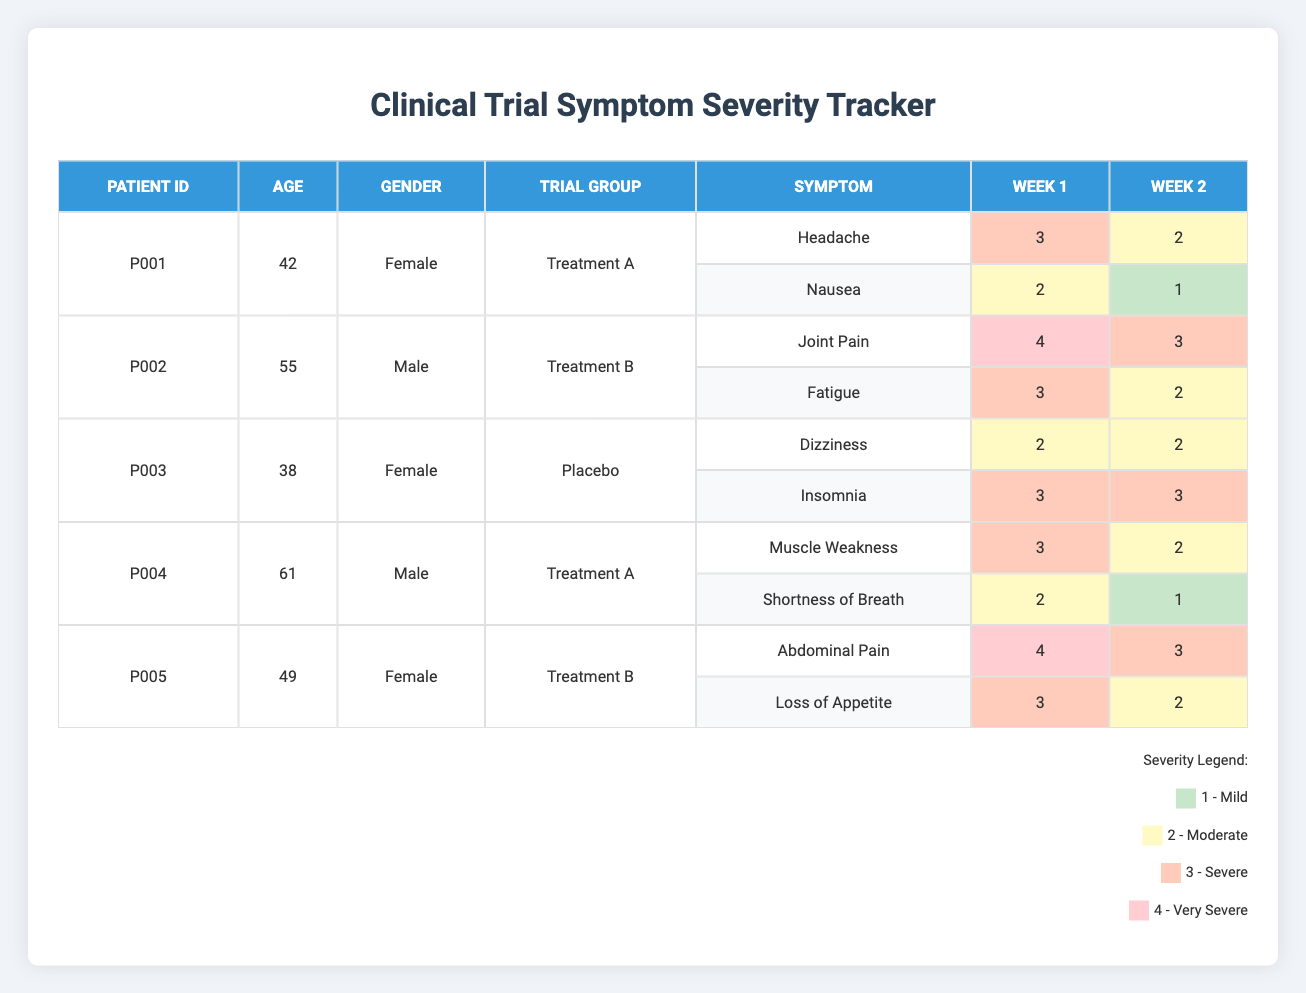What were the symptoms reported by Patient P002 during the first week? Patient P002 reported two symptoms in the first week: Joint Pain with a severity of 4 and Fatigue with a severity of 3. These are found in the table under the entries for Patient P002 in Week 1.
Answer: Joint Pain and Fatigue Which patient showed the highest severity of symptoms during Week 1? Looking at Week 1, Patient P005 reported Abdominal Pain with a severity of 4, which is the highest severity noted among all patients for that week.
Answer: Patient P005 What was the average symptom severity for the treatment group "Treatment A" in Week 2? For Treatment A in Week 2, Patient P001 had two symptoms (severity 2 and 1), and Patient P004 had two symptoms (severity 2 and 1). The total severity was 2 + 1 + 2 + 1 = 6, and there are 4 reported symptoms, so the average severity is 6/4 = 1.5.
Answer: 1.5 Did all patients reported in Week 2 show a decrease in symptom severity compared to Week 1? Comparing severity between Week 1 and Week 2 for each patient shows that P001, P002, and P004 all had a decrease in at least one symptom severity, while P003 and P005 maintained the same severity for one symptom each. Therefore, not all patients showed a decrease.
Answer: No Which symptom had the highest severity among all patients in Week 1 and what was that severity? The highest severity in Week 1 was from Patient P005 with Abdominal Pain at severity 4. This can be identified by comparing all symptoms listed in Week 1 of the table.
Answer: 4 (Abdominal Pain) Was there a patient who reported the same symptom over both weeks, and if so, what was the symptom? Yes, Patient P003 reported Dizziness in both Week 1 and Week 2, with a severity of 2 for each week. This can be found by observing Patient P003’s entries in the table for both weeks.
Answer: Dizziness What is the difference in severity for the symptom "Loss of Appetite" between Week 1 and Week 2? Patient P005 had Loss of Appetite severity of 3 in Week 1 and 2 in Week 2. The difference in severity is calculated as 3 - 2 = 1.
Answer: 1 How many unique symptoms were reported by the patients in total? By reviewing all the symptoms listed for each patient across both weeks in the table, the unique symptoms are Headache, Nausea, Joint Pain, Fatigue, Dizziness, Insomnia, Muscle Weakness, Shortness of Breath, Abdominal Pain, and Loss of Appetite, totaling 10 unique symptoms.
Answer: 10 